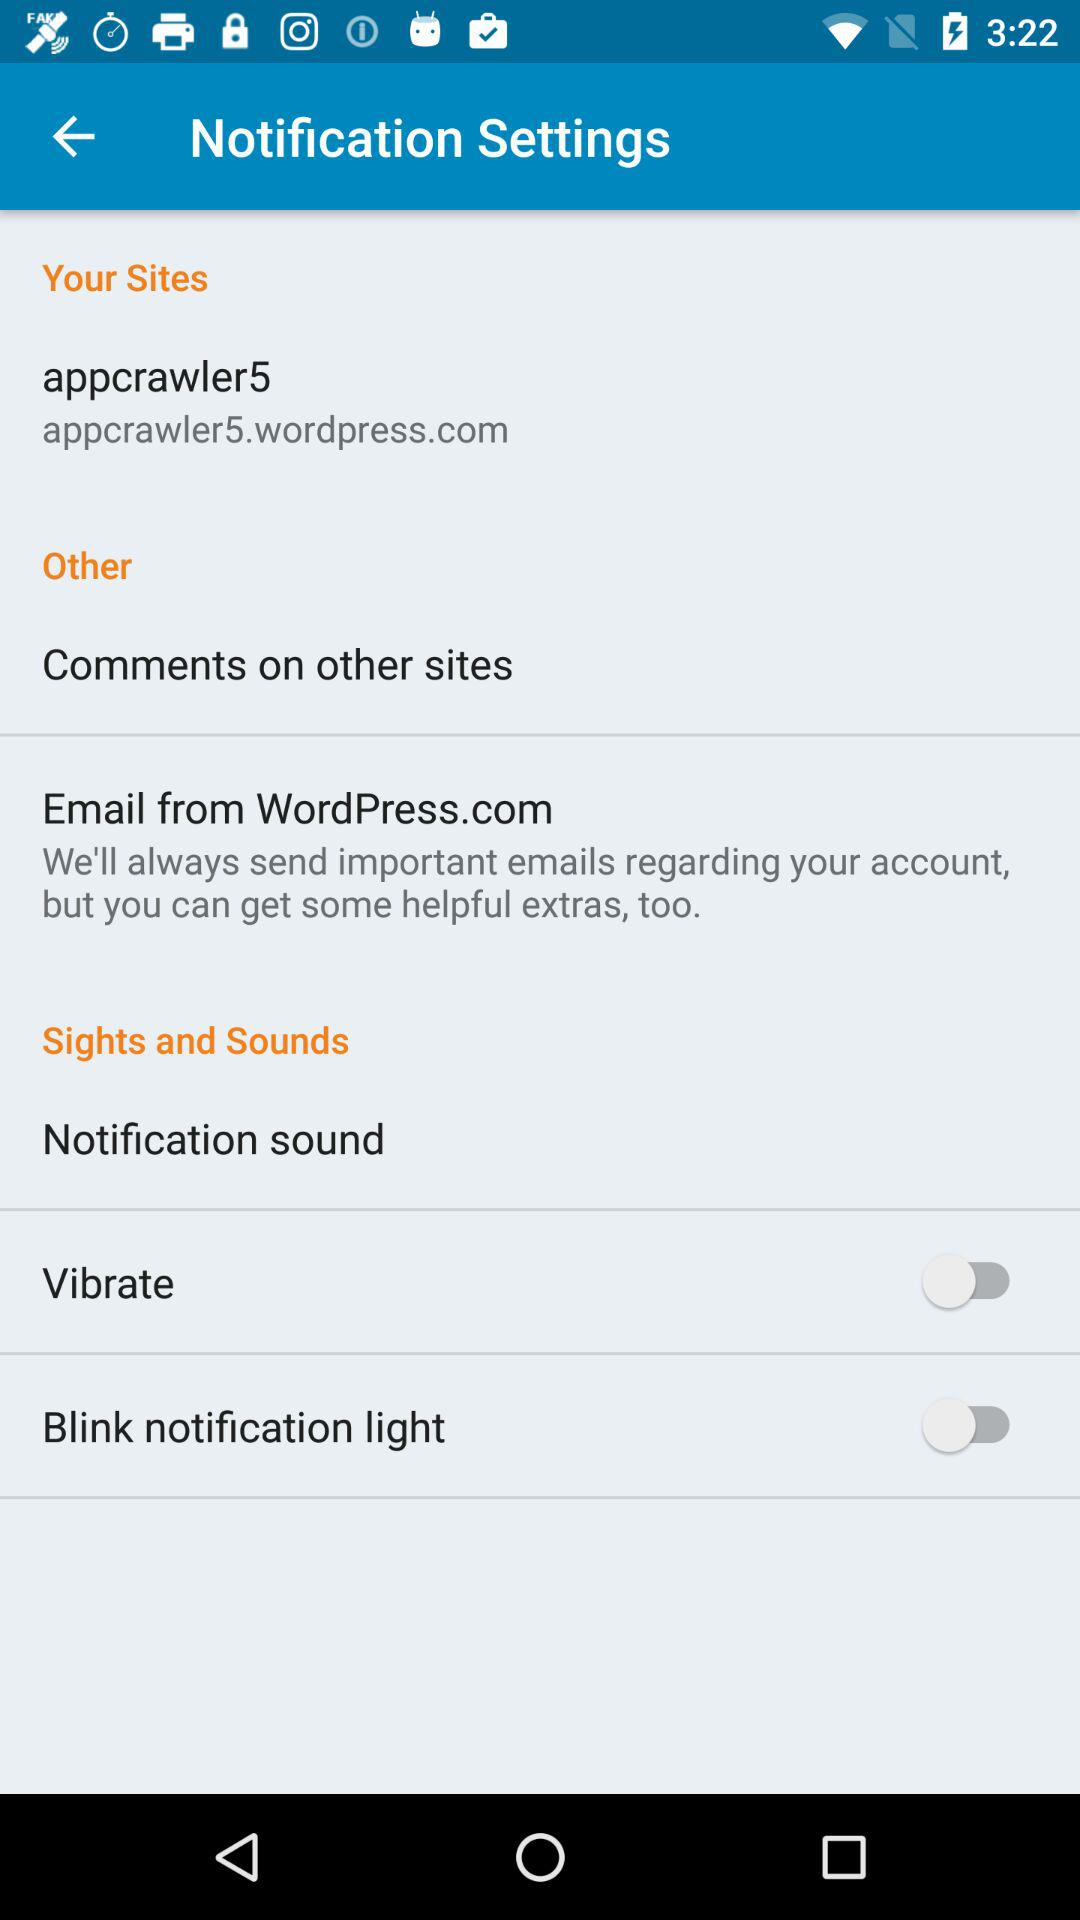What is the status of the "Vibrate" setting? The status is "off'. 